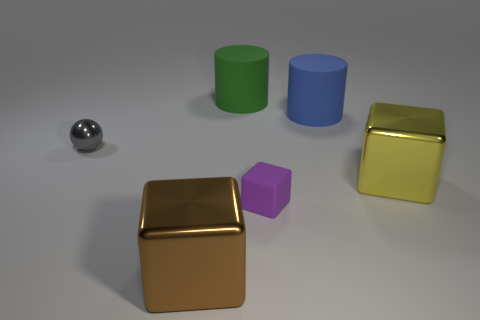Subtract all small purple cubes. How many cubes are left? 2 Add 2 purple rubber cylinders. How many objects exist? 8 Subtract all purple blocks. How many blocks are left? 2 Add 2 balls. How many balls are left? 3 Add 1 small green rubber cylinders. How many small green rubber cylinders exist? 1 Subtract 0 green blocks. How many objects are left? 6 Subtract all cylinders. How many objects are left? 4 Subtract 2 blocks. How many blocks are left? 1 Subtract all red spheres. Subtract all green cubes. How many spheres are left? 1 Subtract all blue cylinders. How many green blocks are left? 0 